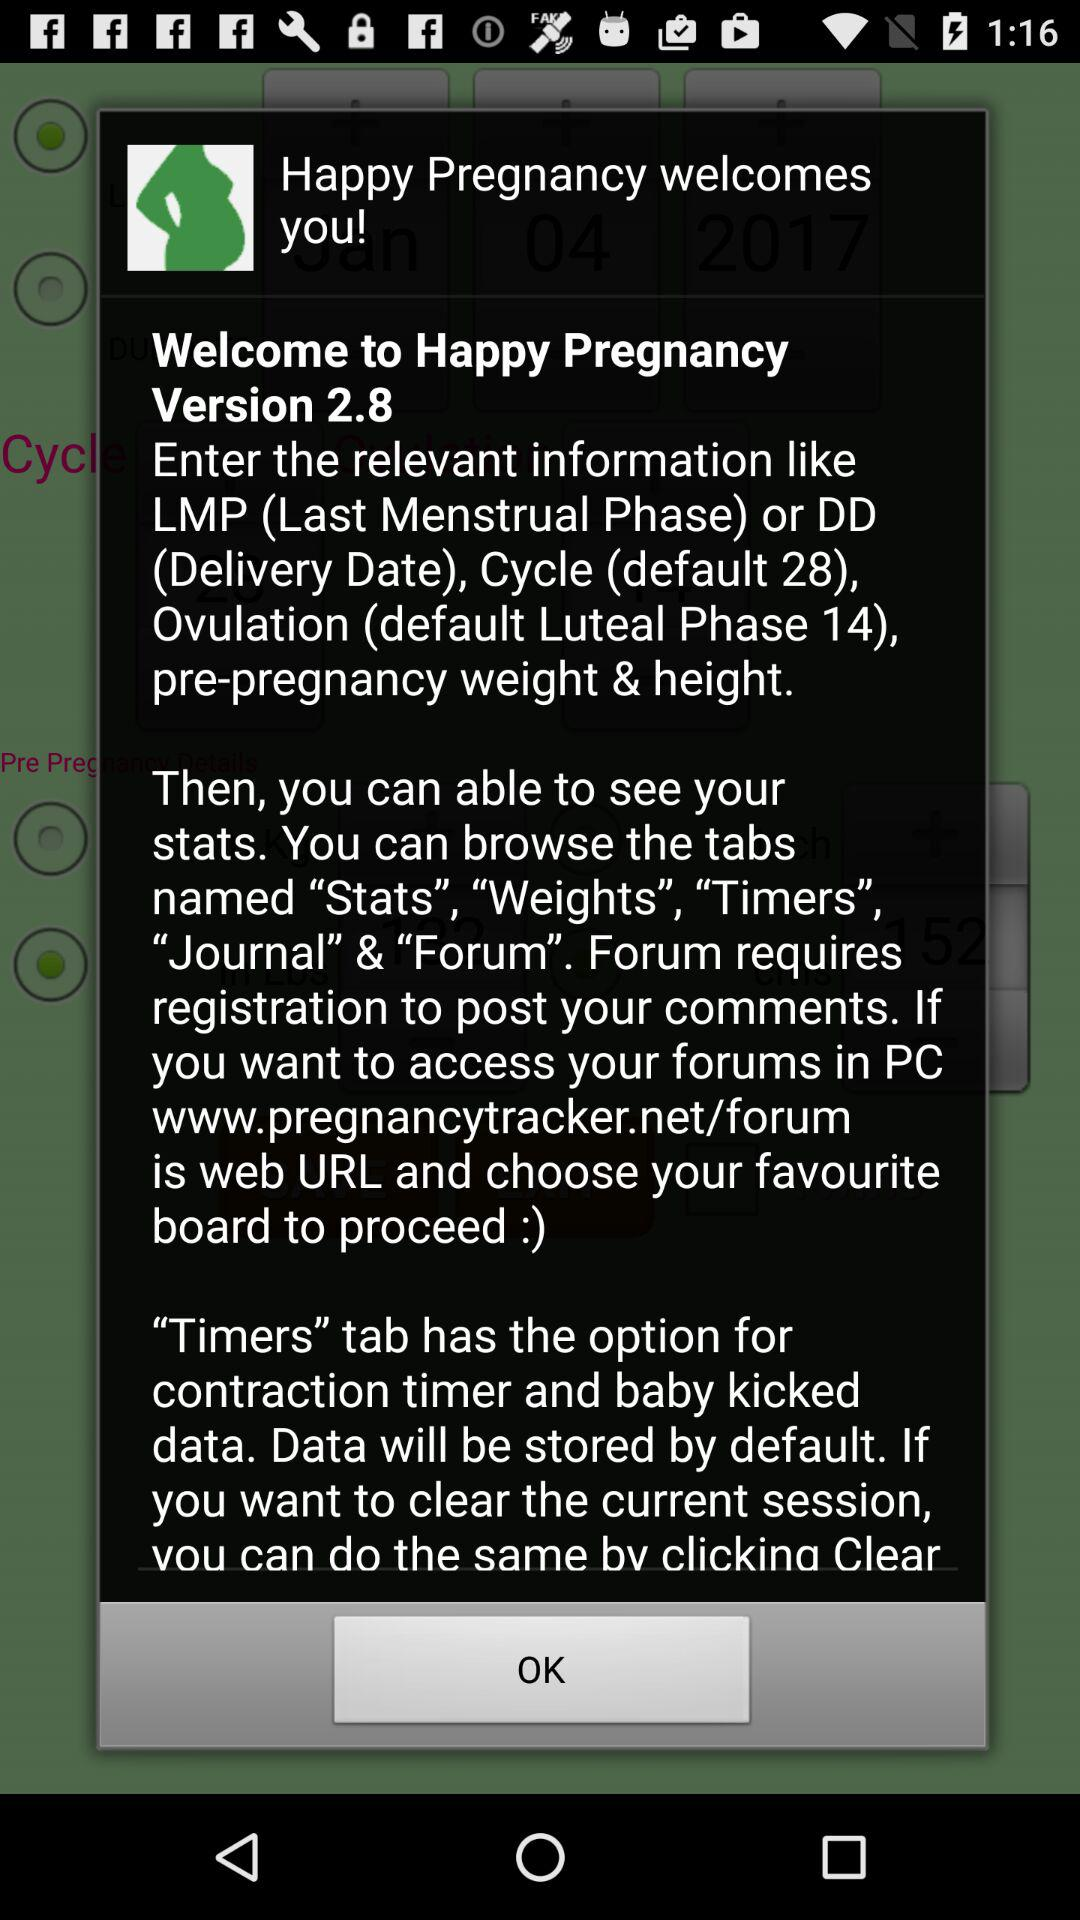How many tabs are there in the app?
Answer the question using a single word or phrase. 5 